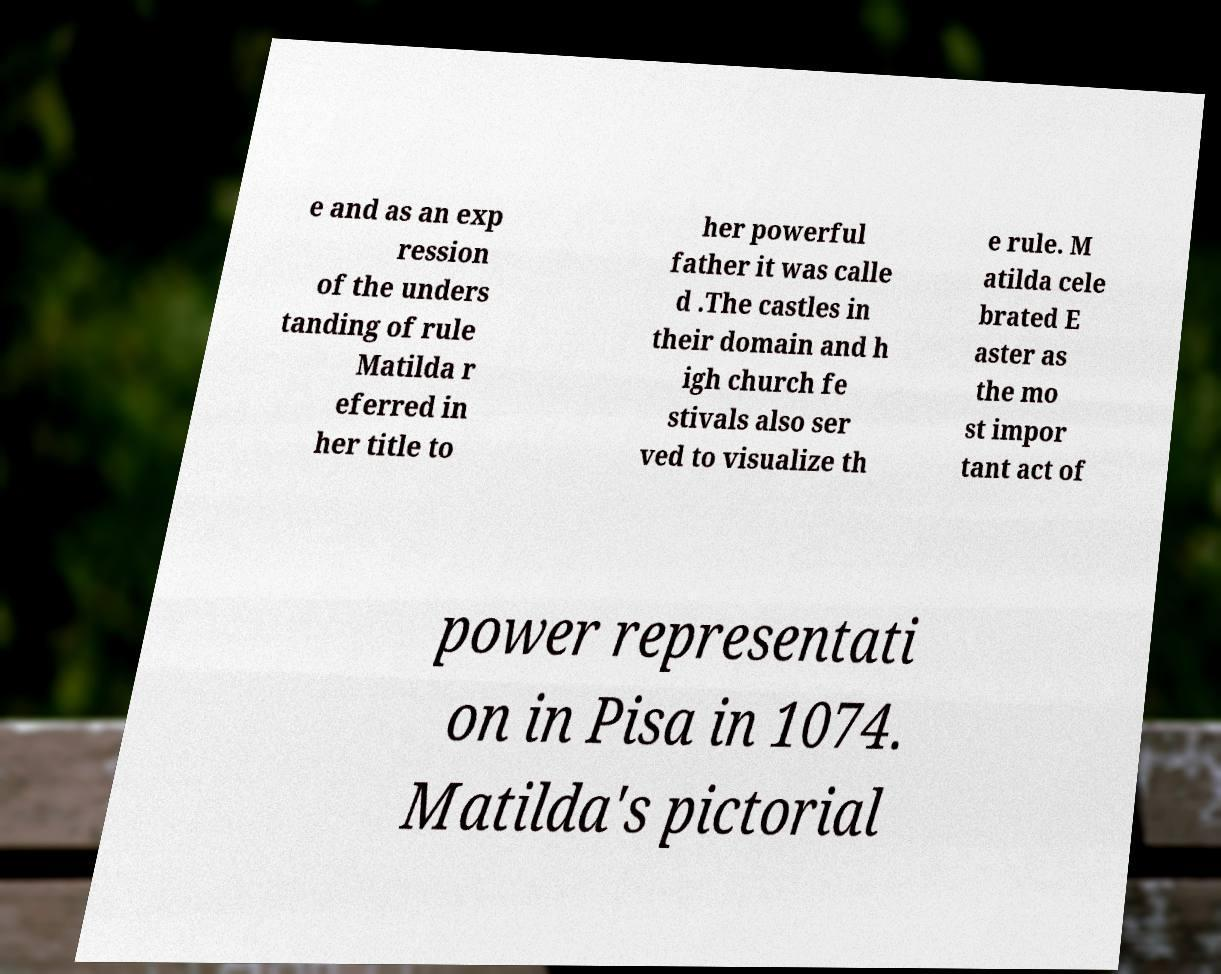For documentation purposes, I need the text within this image transcribed. Could you provide that? e and as an exp ression of the unders tanding of rule Matilda r eferred in her title to her powerful father it was calle d .The castles in their domain and h igh church fe stivals also ser ved to visualize th e rule. M atilda cele brated E aster as the mo st impor tant act of power representati on in Pisa in 1074. Matilda's pictorial 